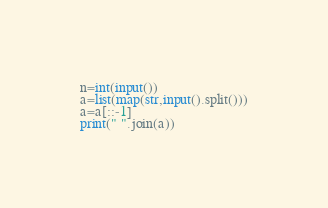Convert code to text. <code><loc_0><loc_0><loc_500><loc_500><_Python_>n=int(input())
a=list(map(str,input().split()))
a=a[::-1]
print(" ".join(a))</code> 